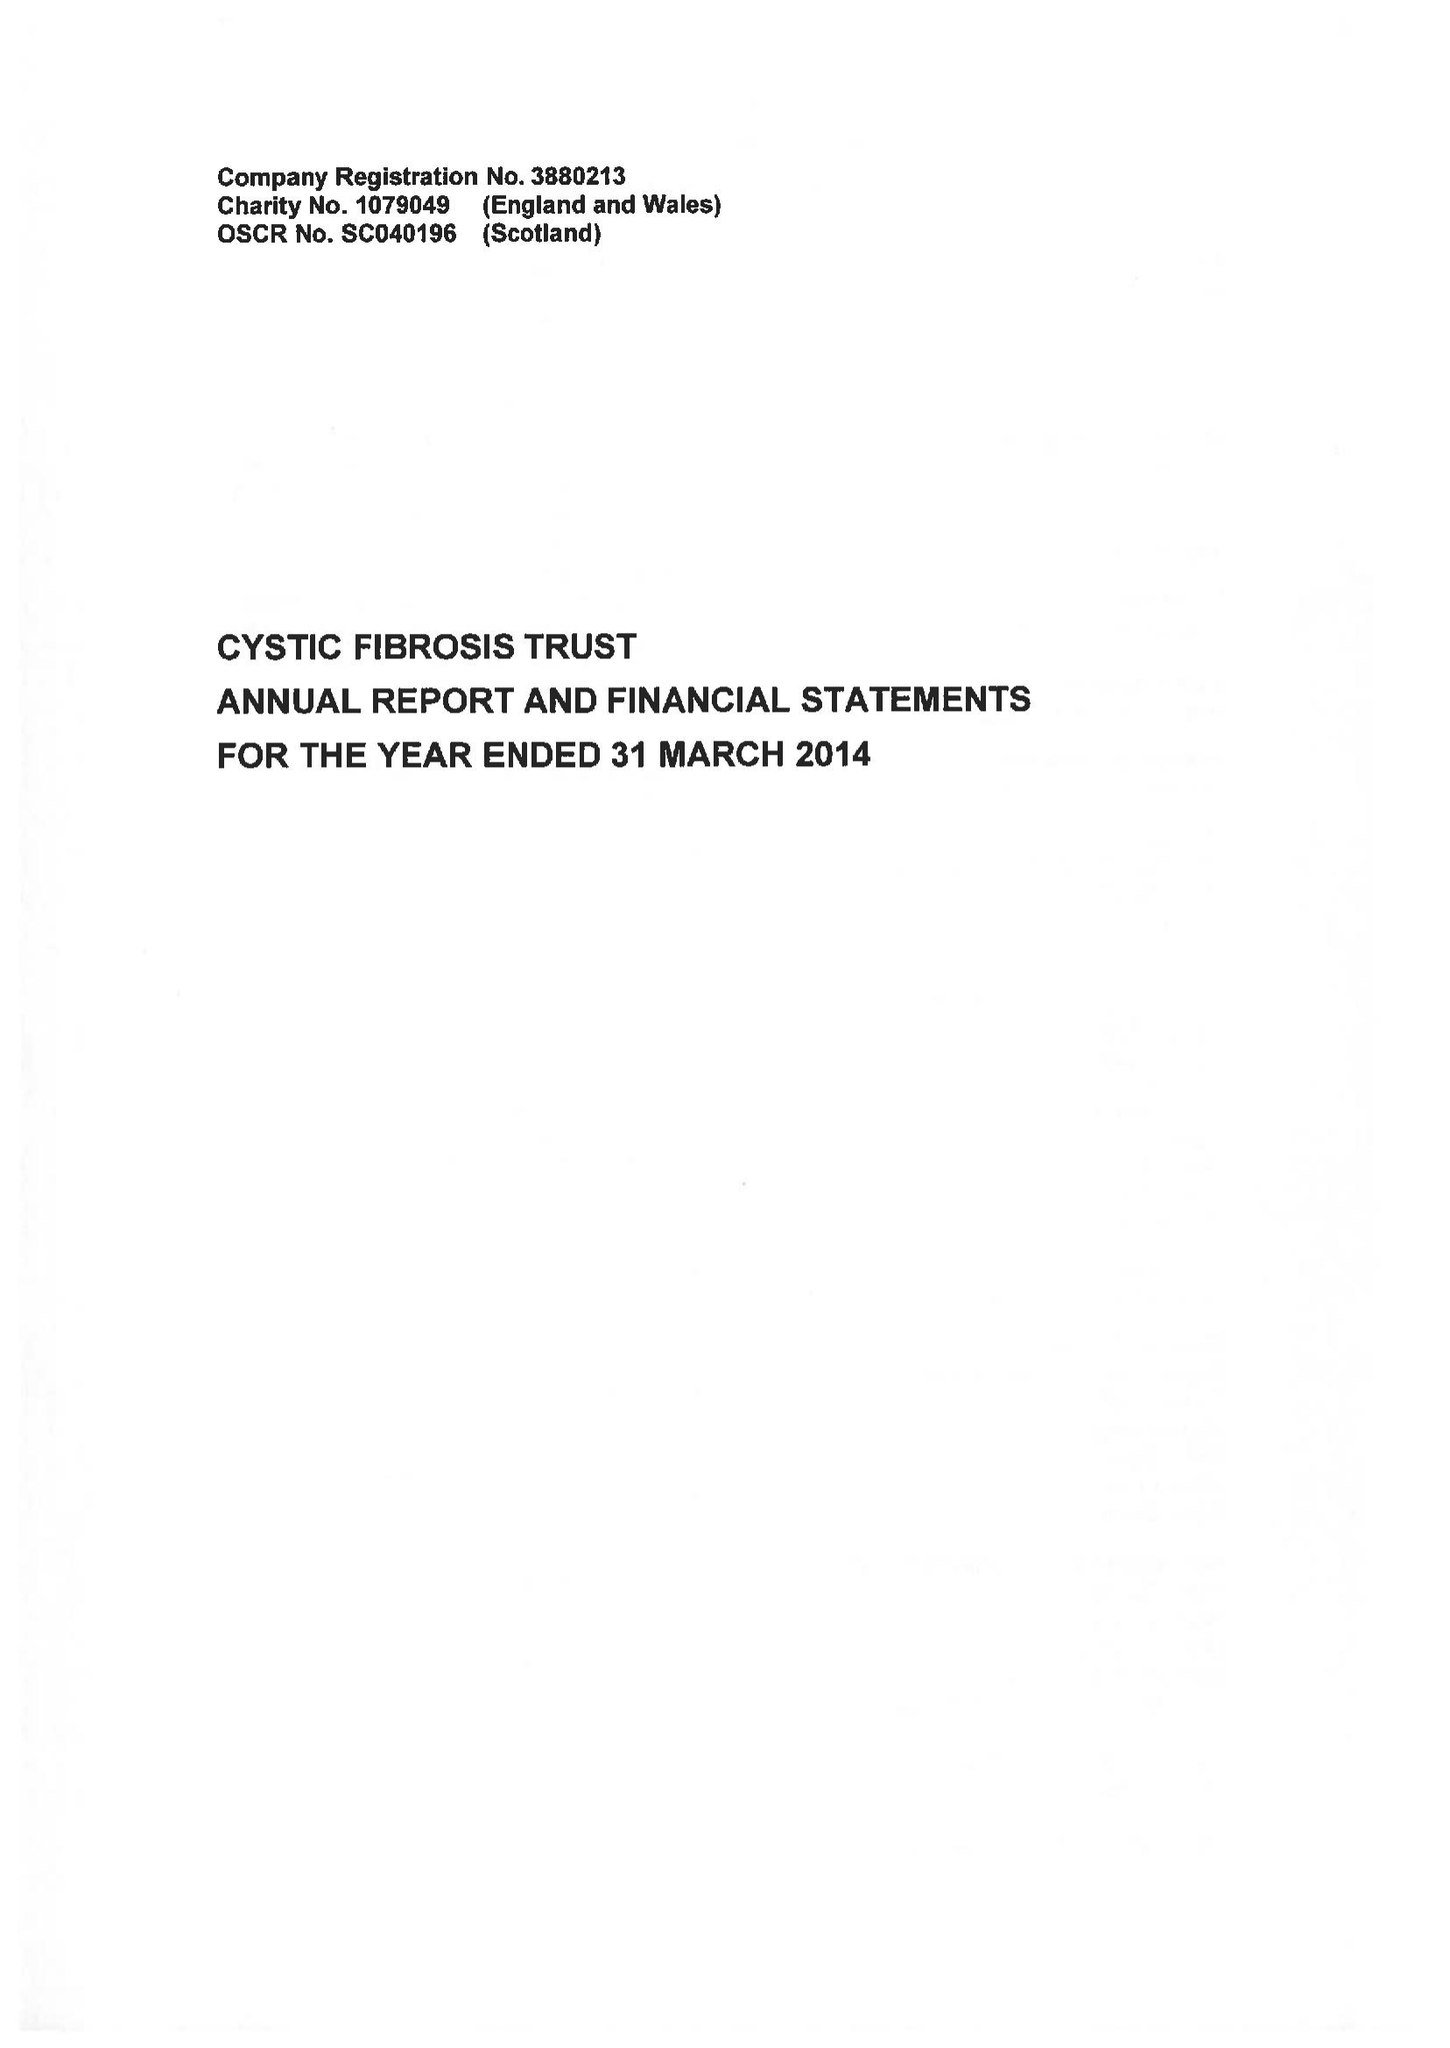What is the value for the spending_annually_in_british_pounds?
Answer the question using a single word or phrase. 10123000.00 